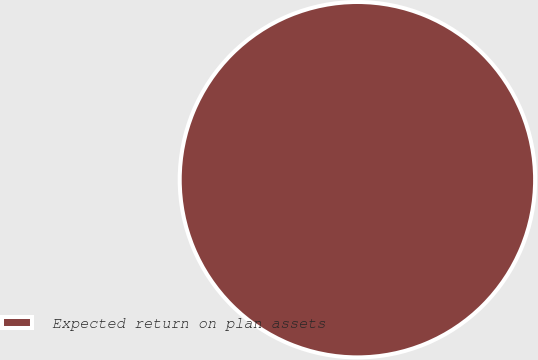Convert chart to OTSL. <chart><loc_0><loc_0><loc_500><loc_500><pie_chart><fcel>Expected return on plan assets<nl><fcel>100.0%<nl></chart> 